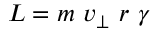Convert formula to latex. <formula><loc_0><loc_0><loc_500><loc_500>L = m \ v _ { \perp } \ r \ \gamma</formula> 